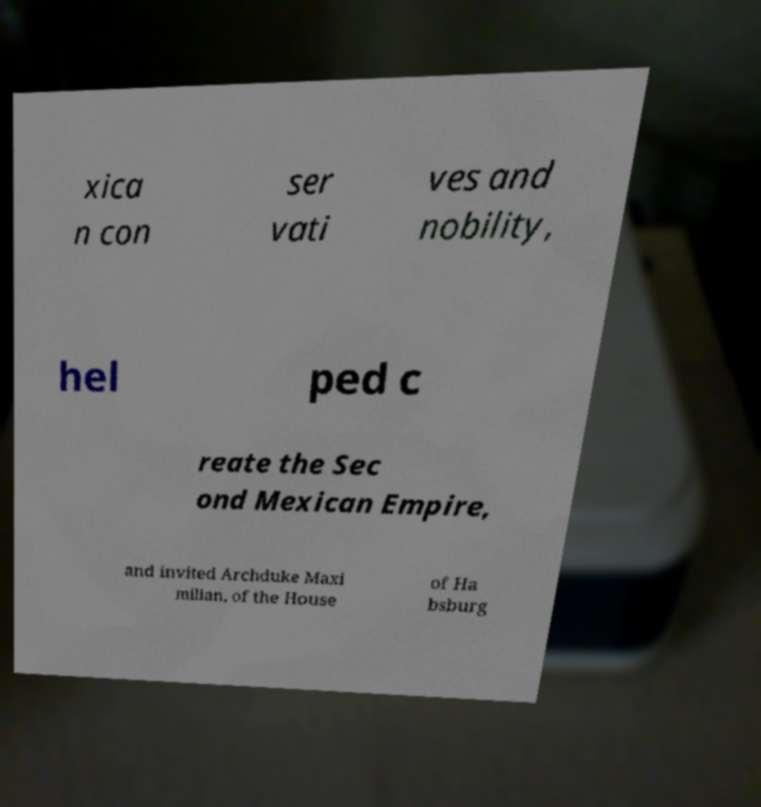For documentation purposes, I need the text within this image transcribed. Could you provide that? xica n con ser vati ves and nobility, hel ped c reate the Sec ond Mexican Empire, and invited Archduke Maxi milian, of the House of Ha bsburg 